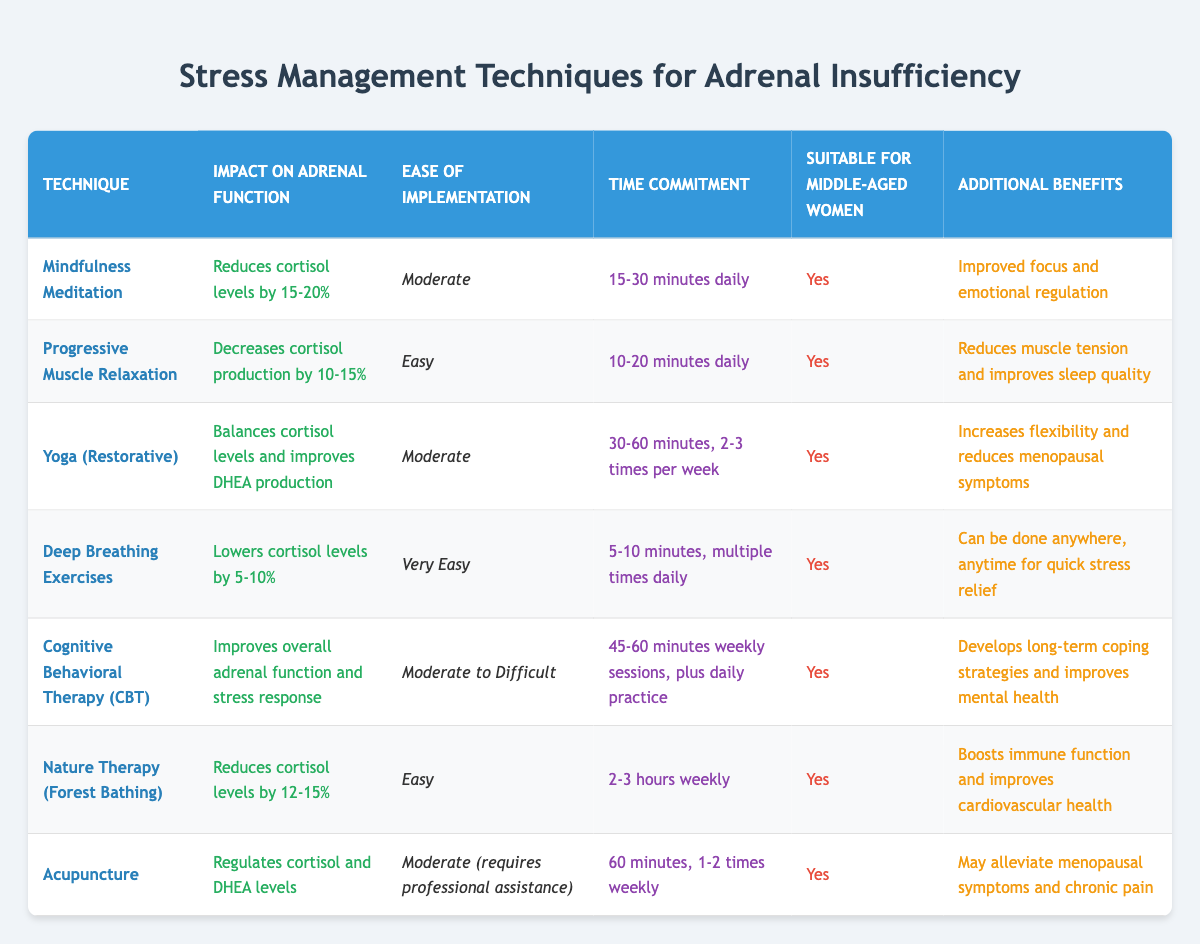What is the technique that lowers cortisol levels by 15-20%? By reviewing the table, we look for the technique under the 'Impact on Adrenal Function' column that specifies a reduction in cortisol levels of 15-20%. This corresponds to 'Mindfulness Meditation'.
Answer: Mindfulness Meditation Which technique has the easiest implementation? In the 'Ease of Implementation' column, we identify which technique is labeled as 'Easy' or 'Very Easy'. Upon checking, 'Deep Breathing Exercises' is marked as 'Very Easy'.
Answer: Deep Breathing Exercises What is the time commitment for Yoga (Restorative)? Looking under the 'Time Commitment' column specifically for Yoga (Restorative), it states that it requires 30-60 minutes, 2-3 times per week.
Answer: 30-60 minutes, 2-3 times per week Is Cognitive Behavioral Therapy (CBT) suitable for middle-aged women? In the 'Suitable for Middle-Aged Women' column, we can directly check if CBT is marked as 'Yes'. The table confirms that it is suitable.
Answer: Yes Which technique has additional benefits related to improving sleep quality? We analyze the 'Additional Benefits' column and see which techniques mention improving sleep quality. 'Progressive Muscle Relaxation' states it improves sleep quality.
Answer: Progressive Muscle Relaxation What is the average cortisol reduction percentage for the techniques listed? We look at the 'Impact on Adrenal Function' percentages: Mindfulness Meditation (17.5%), Progressive Muscle Relaxation (12.5%), Yoga (Restorative) (not quantified but balances), Deep Breathing (7.5%), Nature Therapy (13.5%). First, we note that only specific techniques provided a percentage of reduction. The average is calculated: (17.5 + 12.5 + 7.5 + 13.5) / 4 = 12.5%.
Answer: 12.5% Does Nature Therapy help reduce cortisol levels? In the 'Impact on Adrenal Function' column under Nature Therapy, it is stated that it reduces cortisol levels.
Answer: Yes Which two techniques require a professional for implementation? Checking the 'Ease of Implementation' column, we find that both 'Acupuncture' and 'Cognitive Behavioral Therapy (CBT)' require professional assistance or have a moderate to difficult level.
Answer: Acupuncture, Cognitive Behavioral Therapy (CBT) Which technique is related to both emotional regulation and cortisol reduction? Referring to the 'Impact on Adrenal Function' and 'Additional Benefits' columns, 'Mindfulness Meditation' reduces cortisol levels and also mentions improved emotional regulation.
Answer: Mindfulness Meditation 